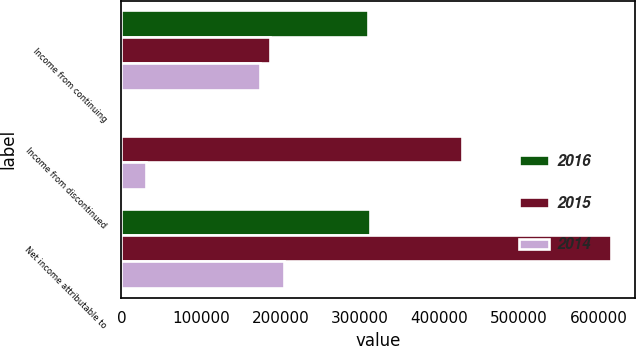Convert chart to OTSL. <chart><loc_0><loc_0><loc_500><loc_500><stacked_bar_chart><ecel><fcel>Income from continuing<fcel>Income from discontinued<fcel>Net income attributable to<nl><fcel>2016<fcel>310156<fcel>1987<fcel>312143<nl><fcel>2015<fcel>187099<fcel>428211<fcel>615310<nl><fcel>2014<fcel>174419<fcel>30474<fcel>204893<nl></chart> 